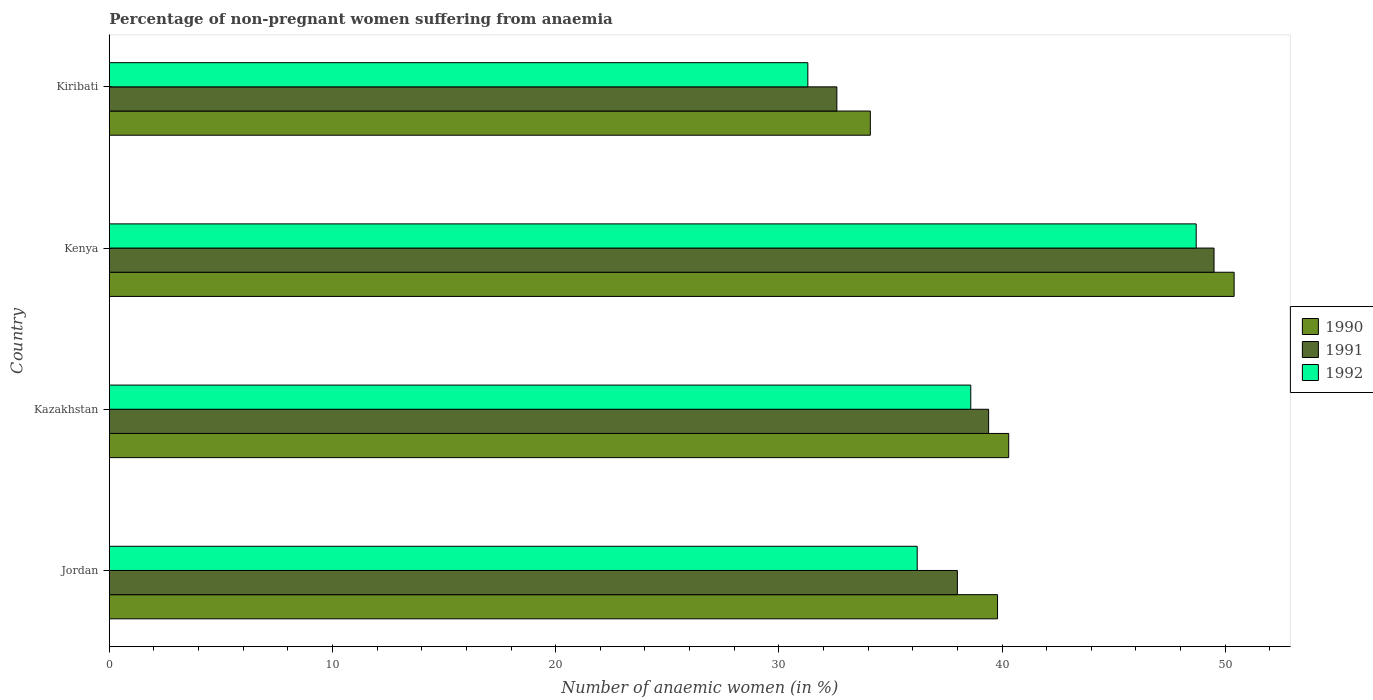How many different coloured bars are there?
Keep it short and to the point. 3. How many bars are there on the 4th tick from the top?
Give a very brief answer. 3. How many bars are there on the 2nd tick from the bottom?
Your answer should be compact. 3. What is the label of the 2nd group of bars from the top?
Offer a very short reply. Kenya. What is the percentage of non-pregnant women suffering from anaemia in 1990 in Kiribati?
Your response must be concise. 34.1. Across all countries, what is the maximum percentage of non-pregnant women suffering from anaemia in 1990?
Your response must be concise. 50.4. Across all countries, what is the minimum percentage of non-pregnant women suffering from anaemia in 1992?
Offer a very short reply. 31.3. In which country was the percentage of non-pregnant women suffering from anaemia in 1991 maximum?
Offer a very short reply. Kenya. In which country was the percentage of non-pregnant women suffering from anaemia in 1991 minimum?
Provide a succinct answer. Kiribati. What is the total percentage of non-pregnant women suffering from anaemia in 1990 in the graph?
Your answer should be very brief. 164.6. What is the difference between the percentage of non-pregnant women suffering from anaemia in 1992 in Jordan and that in Kenya?
Your response must be concise. -12.5. What is the difference between the percentage of non-pregnant women suffering from anaemia in 1992 in Jordan and the percentage of non-pregnant women suffering from anaemia in 1991 in Kiribati?
Your response must be concise. 3.6. What is the average percentage of non-pregnant women suffering from anaemia in 1991 per country?
Give a very brief answer. 39.88. What is the difference between the percentage of non-pregnant women suffering from anaemia in 1992 and percentage of non-pregnant women suffering from anaemia in 1991 in Kenya?
Keep it short and to the point. -0.8. In how many countries, is the percentage of non-pregnant women suffering from anaemia in 1992 greater than 2 %?
Your response must be concise. 4. What is the ratio of the percentage of non-pregnant women suffering from anaemia in 1990 in Kazakhstan to that in Kenya?
Give a very brief answer. 0.8. Is the percentage of non-pregnant women suffering from anaemia in 1990 in Jordan less than that in Kiribati?
Ensure brevity in your answer.  No. Is the difference between the percentage of non-pregnant women suffering from anaemia in 1992 in Jordan and Kenya greater than the difference between the percentage of non-pregnant women suffering from anaemia in 1991 in Jordan and Kenya?
Give a very brief answer. No. What is the difference between the highest and the second highest percentage of non-pregnant women suffering from anaemia in 1990?
Your response must be concise. 10.1. What is the difference between the highest and the lowest percentage of non-pregnant women suffering from anaemia in 1992?
Offer a terse response. 17.4. What does the 2nd bar from the bottom in Jordan represents?
Your answer should be compact. 1991. How many bars are there?
Your response must be concise. 12. Are all the bars in the graph horizontal?
Your response must be concise. Yes. Are the values on the major ticks of X-axis written in scientific E-notation?
Give a very brief answer. No. Does the graph contain any zero values?
Provide a succinct answer. No. Does the graph contain grids?
Offer a terse response. No. Where does the legend appear in the graph?
Offer a terse response. Center right. How many legend labels are there?
Provide a succinct answer. 3. What is the title of the graph?
Ensure brevity in your answer.  Percentage of non-pregnant women suffering from anaemia. What is the label or title of the X-axis?
Give a very brief answer. Number of anaemic women (in %). What is the label or title of the Y-axis?
Your answer should be compact. Country. What is the Number of anaemic women (in %) in 1990 in Jordan?
Offer a terse response. 39.8. What is the Number of anaemic women (in %) in 1991 in Jordan?
Provide a short and direct response. 38. What is the Number of anaemic women (in %) of 1992 in Jordan?
Offer a terse response. 36.2. What is the Number of anaemic women (in %) of 1990 in Kazakhstan?
Your response must be concise. 40.3. What is the Number of anaemic women (in %) in 1991 in Kazakhstan?
Give a very brief answer. 39.4. What is the Number of anaemic women (in %) in 1992 in Kazakhstan?
Your response must be concise. 38.6. What is the Number of anaemic women (in %) of 1990 in Kenya?
Give a very brief answer. 50.4. What is the Number of anaemic women (in %) in 1991 in Kenya?
Your answer should be very brief. 49.5. What is the Number of anaemic women (in %) in 1992 in Kenya?
Make the answer very short. 48.7. What is the Number of anaemic women (in %) in 1990 in Kiribati?
Your answer should be very brief. 34.1. What is the Number of anaemic women (in %) of 1991 in Kiribati?
Offer a very short reply. 32.6. What is the Number of anaemic women (in %) of 1992 in Kiribati?
Your answer should be compact. 31.3. Across all countries, what is the maximum Number of anaemic women (in %) of 1990?
Offer a terse response. 50.4. Across all countries, what is the maximum Number of anaemic women (in %) of 1991?
Make the answer very short. 49.5. Across all countries, what is the maximum Number of anaemic women (in %) of 1992?
Provide a succinct answer. 48.7. Across all countries, what is the minimum Number of anaemic women (in %) in 1990?
Provide a short and direct response. 34.1. Across all countries, what is the minimum Number of anaemic women (in %) of 1991?
Provide a succinct answer. 32.6. Across all countries, what is the minimum Number of anaemic women (in %) of 1992?
Your response must be concise. 31.3. What is the total Number of anaemic women (in %) of 1990 in the graph?
Offer a terse response. 164.6. What is the total Number of anaemic women (in %) of 1991 in the graph?
Ensure brevity in your answer.  159.5. What is the total Number of anaemic women (in %) of 1992 in the graph?
Your answer should be very brief. 154.8. What is the difference between the Number of anaemic women (in %) of 1991 in Jordan and that in Kazakhstan?
Keep it short and to the point. -1.4. What is the difference between the Number of anaemic women (in %) in 1992 in Jordan and that in Kazakhstan?
Your answer should be compact. -2.4. What is the difference between the Number of anaemic women (in %) in 1991 in Jordan and that in Kenya?
Provide a succinct answer. -11.5. What is the difference between the Number of anaemic women (in %) of 1992 in Jordan and that in Kenya?
Your response must be concise. -12.5. What is the difference between the Number of anaemic women (in %) in 1990 in Jordan and that in Kiribati?
Your response must be concise. 5.7. What is the difference between the Number of anaemic women (in %) of 1991 in Jordan and that in Kiribati?
Offer a terse response. 5.4. What is the difference between the Number of anaemic women (in %) in 1992 in Jordan and that in Kiribati?
Keep it short and to the point. 4.9. What is the difference between the Number of anaemic women (in %) in 1990 in Kazakhstan and that in Kiribati?
Offer a terse response. 6.2. What is the difference between the Number of anaemic women (in %) in 1992 in Kazakhstan and that in Kiribati?
Make the answer very short. 7.3. What is the difference between the Number of anaemic women (in %) of 1991 in Kenya and that in Kiribati?
Provide a short and direct response. 16.9. What is the difference between the Number of anaemic women (in %) in 1990 in Jordan and the Number of anaemic women (in %) in 1992 in Kazakhstan?
Give a very brief answer. 1.2. What is the difference between the Number of anaemic women (in %) of 1991 in Jordan and the Number of anaemic women (in %) of 1992 in Kazakhstan?
Your response must be concise. -0.6. What is the difference between the Number of anaemic women (in %) of 1991 in Jordan and the Number of anaemic women (in %) of 1992 in Kenya?
Provide a short and direct response. -10.7. What is the difference between the Number of anaemic women (in %) of 1990 in Jordan and the Number of anaemic women (in %) of 1991 in Kiribati?
Your response must be concise. 7.2. What is the difference between the Number of anaemic women (in %) in 1990 in Kazakhstan and the Number of anaemic women (in %) in 1991 in Kenya?
Your response must be concise. -9.2. What is the difference between the Number of anaemic women (in %) of 1990 in Kazakhstan and the Number of anaemic women (in %) of 1992 in Kenya?
Make the answer very short. -8.4. What is the difference between the Number of anaemic women (in %) of 1990 in Kenya and the Number of anaemic women (in %) of 1991 in Kiribati?
Give a very brief answer. 17.8. What is the difference between the Number of anaemic women (in %) of 1990 in Kenya and the Number of anaemic women (in %) of 1992 in Kiribati?
Your answer should be very brief. 19.1. What is the difference between the Number of anaemic women (in %) in 1991 in Kenya and the Number of anaemic women (in %) in 1992 in Kiribati?
Make the answer very short. 18.2. What is the average Number of anaemic women (in %) of 1990 per country?
Keep it short and to the point. 41.15. What is the average Number of anaemic women (in %) of 1991 per country?
Offer a terse response. 39.88. What is the average Number of anaemic women (in %) in 1992 per country?
Ensure brevity in your answer.  38.7. What is the difference between the Number of anaemic women (in %) in 1990 and Number of anaemic women (in %) in 1992 in Jordan?
Give a very brief answer. 3.6. What is the difference between the Number of anaemic women (in %) in 1991 and Number of anaemic women (in %) in 1992 in Jordan?
Your response must be concise. 1.8. What is the difference between the Number of anaemic women (in %) in 1991 and Number of anaemic women (in %) in 1992 in Kazakhstan?
Your answer should be compact. 0.8. What is the difference between the Number of anaemic women (in %) in 1990 and Number of anaemic women (in %) in 1992 in Kiribati?
Your answer should be very brief. 2.8. What is the ratio of the Number of anaemic women (in %) in 1990 in Jordan to that in Kazakhstan?
Provide a succinct answer. 0.99. What is the ratio of the Number of anaemic women (in %) of 1991 in Jordan to that in Kazakhstan?
Give a very brief answer. 0.96. What is the ratio of the Number of anaemic women (in %) in 1992 in Jordan to that in Kazakhstan?
Your answer should be compact. 0.94. What is the ratio of the Number of anaemic women (in %) of 1990 in Jordan to that in Kenya?
Ensure brevity in your answer.  0.79. What is the ratio of the Number of anaemic women (in %) in 1991 in Jordan to that in Kenya?
Give a very brief answer. 0.77. What is the ratio of the Number of anaemic women (in %) in 1992 in Jordan to that in Kenya?
Provide a succinct answer. 0.74. What is the ratio of the Number of anaemic women (in %) of 1990 in Jordan to that in Kiribati?
Offer a very short reply. 1.17. What is the ratio of the Number of anaemic women (in %) in 1991 in Jordan to that in Kiribati?
Ensure brevity in your answer.  1.17. What is the ratio of the Number of anaemic women (in %) in 1992 in Jordan to that in Kiribati?
Provide a succinct answer. 1.16. What is the ratio of the Number of anaemic women (in %) of 1990 in Kazakhstan to that in Kenya?
Your response must be concise. 0.8. What is the ratio of the Number of anaemic women (in %) of 1991 in Kazakhstan to that in Kenya?
Give a very brief answer. 0.8. What is the ratio of the Number of anaemic women (in %) of 1992 in Kazakhstan to that in Kenya?
Ensure brevity in your answer.  0.79. What is the ratio of the Number of anaemic women (in %) of 1990 in Kazakhstan to that in Kiribati?
Give a very brief answer. 1.18. What is the ratio of the Number of anaemic women (in %) in 1991 in Kazakhstan to that in Kiribati?
Your answer should be very brief. 1.21. What is the ratio of the Number of anaemic women (in %) in 1992 in Kazakhstan to that in Kiribati?
Your answer should be very brief. 1.23. What is the ratio of the Number of anaemic women (in %) of 1990 in Kenya to that in Kiribati?
Make the answer very short. 1.48. What is the ratio of the Number of anaemic women (in %) in 1991 in Kenya to that in Kiribati?
Make the answer very short. 1.52. What is the ratio of the Number of anaemic women (in %) of 1992 in Kenya to that in Kiribati?
Make the answer very short. 1.56. What is the difference between the highest and the second highest Number of anaemic women (in %) in 1990?
Keep it short and to the point. 10.1. What is the difference between the highest and the second highest Number of anaemic women (in %) of 1991?
Keep it short and to the point. 10.1. 